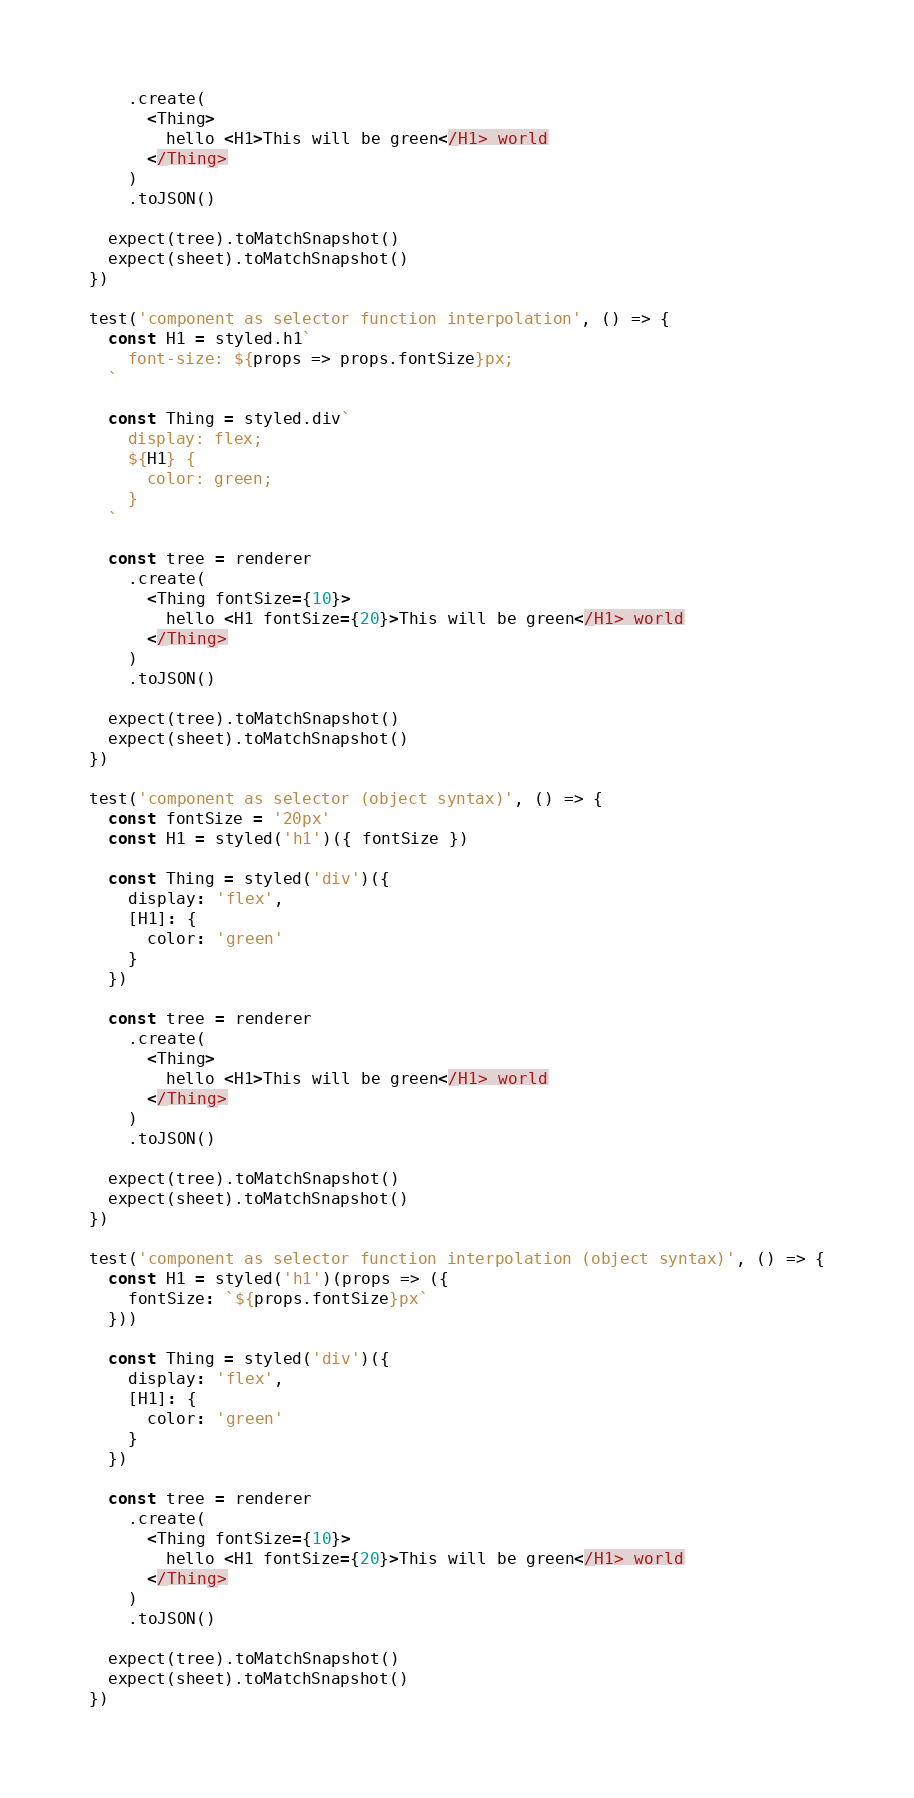Convert code to text. <code><loc_0><loc_0><loc_500><loc_500><_JavaScript_>    .create(
      <Thing>
        hello <H1>This will be green</H1> world
      </Thing>
    )
    .toJSON()

  expect(tree).toMatchSnapshot()
  expect(sheet).toMatchSnapshot()
})

test('component as selector function interpolation', () => {
  const H1 = styled.h1`
    font-size: ${props => props.fontSize}px;
  `

  const Thing = styled.div`
    display: flex;
    ${H1} {
      color: green;
    }
  `

  const tree = renderer
    .create(
      <Thing fontSize={10}>
        hello <H1 fontSize={20}>This will be green</H1> world
      </Thing>
    )
    .toJSON()

  expect(tree).toMatchSnapshot()
  expect(sheet).toMatchSnapshot()
})

test('component as selector (object syntax)', () => {
  const fontSize = '20px'
  const H1 = styled('h1')({ fontSize })

  const Thing = styled('div')({
    display: 'flex',
    [H1]: {
      color: 'green'
    }
  })

  const tree = renderer
    .create(
      <Thing>
        hello <H1>This will be green</H1> world
      </Thing>
    )
    .toJSON()

  expect(tree).toMatchSnapshot()
  expect(sheet).toMatchSnapshot()
})

test('component as selector function interpolation (object syntax)', () => {
  const H1 = styled('h1')(props => ({
    fontSize: `${props.fontSize}px`
  }))

  const Thing = styled('div')({
    display: 'flex',
    [H1]: {
      color: 'green'
    }
  })

  const tree = renderer
    .create(
      <Thing fontSize={10}>
        hello <H1 fontSize={20}>This will be green</H1> world
      </Thing>
    )
    .toJSON()

  expect(tree).toMatchSnapshot()
  expect(sheet).toMatchSnapshot()
})
</code> 